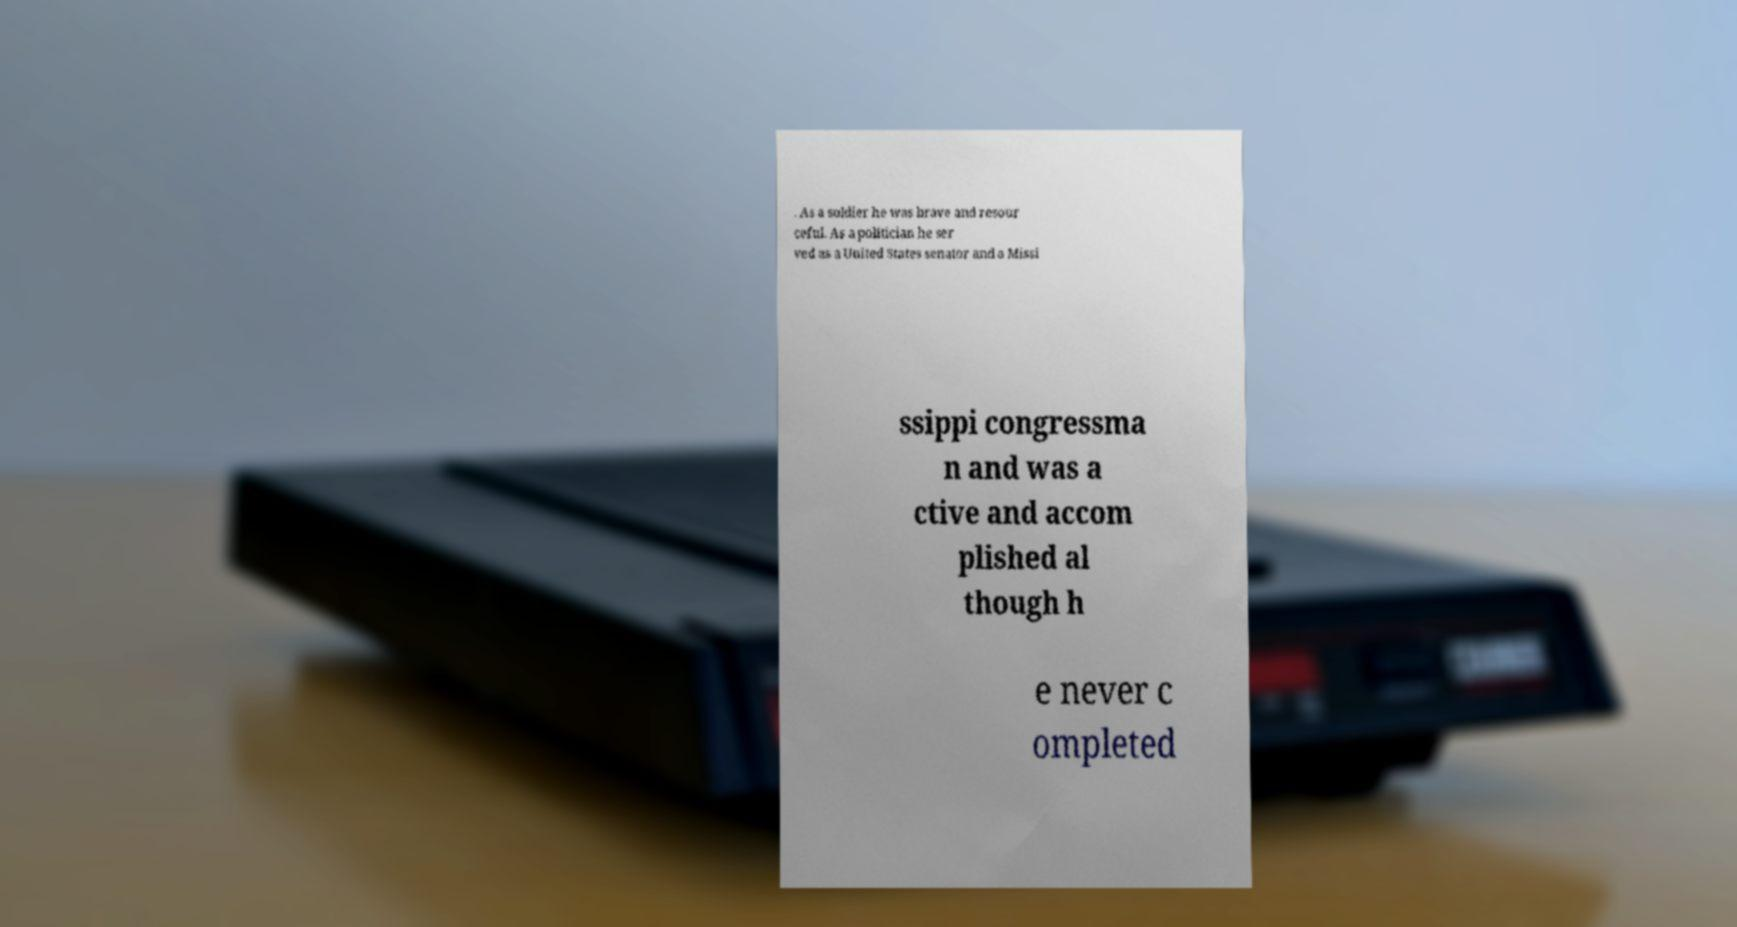There's text embedded in this image that I need extracted. Can you transcribe it verbatim? . As a soldier he was brave and resour ceful. As a politician he ser ved as a United States senator and a Missi ssippi congressma n and was a ctive and accom plished al though h e never c ompleted 